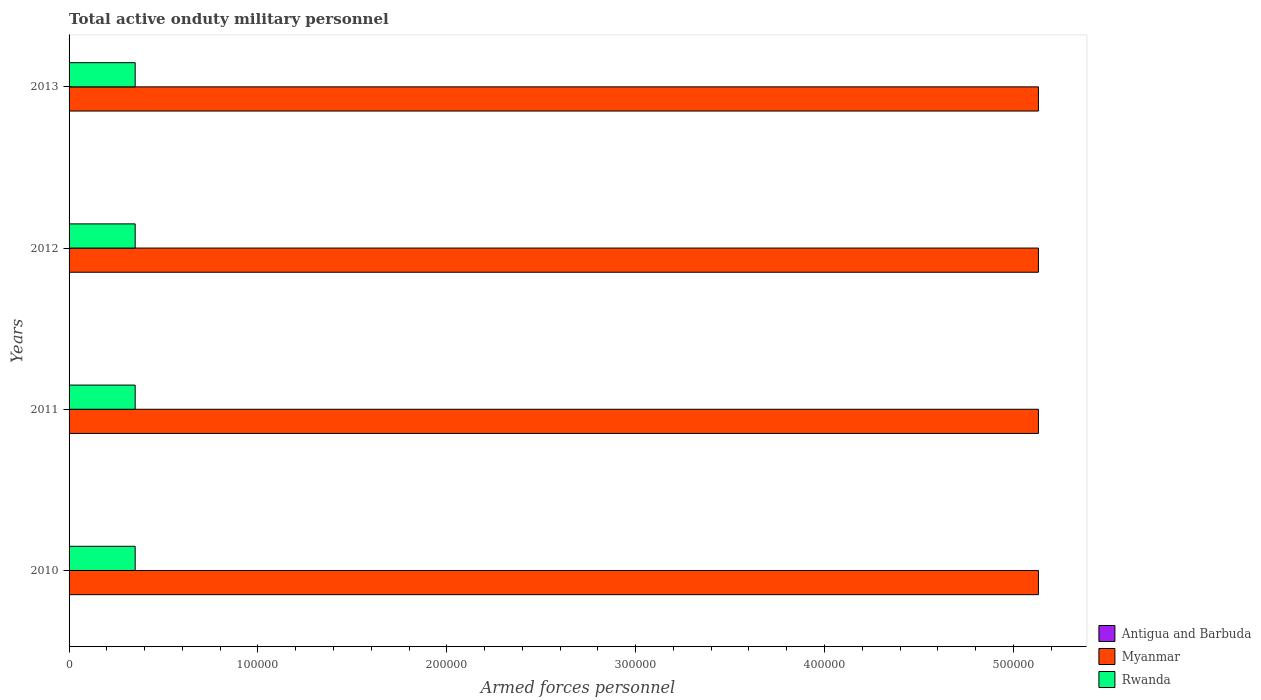Are the number of bars on each tick of the Y-axis equal?
Your response must be concise. Yes. How many bars are there on the 1st tick from the top?
Make the answer very short. 3. How many bars are there on the 2nd tick from the bottom?
Ensure brevity in your answer.  3. What is the label of the 1st group of bars from the top?
Keep it short and to the point. 2013. In how many cases, is the number of bars for a given year not equal to the number of legend labels?
Ensure brevity in your answer.  0. What is the number of armed forces personnel in Myanmar in 2010?
Offer a terse response. 5.13e+05. Across all years, what is the maximum number of armed forces personnel in Rwanda?
Offer a very short reply. 3.50e+04. Across all years, what is the minimum number of armed forces personnel in Rwanda?
Offer a very short reply. 3.50e+04. In which year was the number of armed forces personnel in Antigua and Barbuda maximum?
Your answer should be compact. 2011. What is the total number of armed forces personnel in Myanmar in the graph?
Give a very brief answer. 2.05e+06. What is the difference between the number of armed forces personnel in Rwanda in 2010 and the number of armed forces personnel in Myanmar in 2011?
Your answer should be very brief. -4.78e+05. What is the average number of armed forces personnel in Antigua and Barbuda per year?
Keep it short and to the point. 177.5. In the year 2011, what is the difference between the number of armed forces personnel in Myanmar and number of armed forces personnel in Antigua and Barbuda?
Keep it short and to the point. 5.13e+05. In how many years, is the number of armed forces personnel in Myanmar greater than 360000 ?
Provide a succinct answer. 4. Is the number of armed forces personnel in Antigua and Barbuda in 2010 less than that in 2012?
Give a very brief answer. Yes. What is the difference between the highest and the second highest number of armed forces personnel in Rwanda?
Provide a short and direct response. 0. What is the difference between the highest and the lowest number of armed forces personnel in Myanmar?
Make the answer very short. 0. In how many years, is the number of armed forces personnel in Rwanda greater than the average number of armed forces personnel in Rwanda taken over all years?
Provide a short and direct response. 0. What does the 3rd bar from the top in 2010 represents?
Keep it short and to the point. Antigua and Barbuda. What does the 3rd bar from the bottom in 2011 represents?
Provide a short and direct response. Rwanda. Is it the case that in every year, the sum of the number of armed forces personnel in Antigua and Barbuda and number of armed forces personnel in Myanmar is greater than the number of armed forces personnel in Rwanda?
Your answer should be very brief. Yes. Are all the bars in the graph horizontal?
Offer a very short reply. Yes. How many years are there in the graph?
Offer a very short reply. 4. What is the difference between two consecutive major ticks on the X-axis?
Provide a succinct answer. 1.00e+05. Are the values on the major ticks of X-axis written in scientific E-notation?
Give a very brief answer. No. Does the graph contain grids?
Offer a terse response. No. Where does the legend appear in the graph?
Your answer should be very brief. Bottom right. What is the title of the graph?
Your response must be concise. Total active onduty military personnel. What is the label or title of the X-axis?
Make the answer very short. Armed forces personnel. What is the label or title of the Y-axis?
Provide a short and direct response. Years. What is the Armed forces personnel of Antigua and Barbuda in 2010?
Give a very brief answer. 170. What is the Armed forces personnel of Myanmar in 2010?
Offer a terse response. 5.13e+05. What is the Armed forces personnel of Rwanda in 2010?
Your response must be concise. 3.50e+04. What is the Armed forces personnel of Antigua and Barbuda in 2011?
Give a very brief answer. 180. What is the Armed forces personnel of Myanmar in 2011?
Your answer should be very brief. 5.13e+05. What is the Armed forces personnel in Rwanda in 2011?
Your answer should be compact. 3.50e+04. What is the Armed forces personnel in Antigua and Barbuda in 2012?
Offer a very short reply. 180. What is the Armed forces personnel in Myanmar in 2012?
Offer a very short reply. 5.13e+05. What is the Armed forces personnel of Rwanda in 2012?
Your answer should be compact. 3.50e+04. What is the Armed forces personnel in Antigua and Barbuda in 2013?
Offer a terse response. 180. What is the Armed forces personnel of Myanmar in 2013?
Make the answer very short. 5.13e+05. What is the Armed forces personnel of Rwanda in 2013?
Give a very brief answer. 3.50e+04. Across all years, what is the maximum Armed forces personnel of Antigua and Barbuda?
Ensure brevity in your answer.  180. Across all years, what is the maximum Armed forces personnel of Myanmar?
Offer a terse response. 5.13e+05. Across all years, what is the maximum Armed forces personnel in Rwanda?
Your answer should be very brief. 3.50e+04. Across all years, what is the minimum Armed forces personnel of Antigua and Barbuda?
Make the answer very short. 170. Across all years, what is the minimum Armed forces personnel in Myanmar?
Make the answer very short. 5.13e+05. Across all years, what is the minimum Armed forces personnel in Rwanda?
Provide a short and direct response. 3.50e+04. What is the total Armed forces personnel of Antigua and Barbuda in the graph?
Make the answer very short. 710. What is the total Armed forces personnel of Myanmar in the graph?
Your answer should be very brief. 2.05e+06. What is the difference between the Armed forces personnel in Rwanda in 2010 and that in 2011?
Keep it short and to the point. 0. What is the difference between the Armed forces personnel of Rwanda in 2010 and that in 2012?
Your answer should be very brief. 0. What is the difference between the Armed forces personnel in Myanmar in 2010 and that in 2013?
Ensure brevity in your answer.  0. What is the difference between the Armed forces personnel of Rwanda in 2010 and that in 2013?
Offer a very short reply. 0. What is the difference between the Armed forces personnel of Myanmar in 2011 and that in 2013?
Provide a short and direct response. 0. What is the difference between the Armed forces personnel in Rwanda in 2011 and that in 2013?
Offer a very short reply. 0. What is the difference between the Armed forces personnel of Antigua and Barbuda in 2012 and that in 2013?
Provide a succinct answer. 0. What is the difference between the Armed forces personnel of Myanmar in 2012 and that in 2013?
Give a very brief answer. 0. What is the difference between the Armed forces personnel of Antigua and Barbuda in 2010 and the Armed forces personnel of Myanmar in 2011?
Provide a short and direct response. -5.13e+05. What is the difference between the Armed forces personnel in Antigua and Barbuda in 2010 and the Armed forces personnel in Rwanda in 2011?
Offer a terse response. -3.48e+04. What is the difference between the Armed forces personnel of Myanmar in 2010 and the Armed forces personnel of Rwanda in 2011?
Your answer should be very brief. 4.78e+05. What is the difference between the Armed forces personnel of Antigua and Barbuda in 2010 and the Armed forces personnel of Myanmar in 2012?
Your response must be concise. -5.13e+05. What is the difference between the Armed forces personnel of Antigua and Barbuda in 2010 and the Armed forces personnel of Rwanda in 2012?
Offer a terse response. -3.48e+04. What is the difference between the Armed forces personnel in Myanmar in 2010 and the Armed forces personnel in Rwanda in 2012?
Provide a succinct answer. 4.78e+05. What is the difference between the Armed forces personnel in Antigua and Barbuda in 2010 and the Armed forces personnel in Myanmar in 2013?
Make the answer very short. -5.13e+05. What is the difference between the Armed forces personnel in Antigua and Barbuda in 2010 and the Armed forces personnel in Rwanda in 2013?
Ensure brevity in your answer.  -3.48e+04. What is the difference between the Armed forces personnel in Myanmar in 2010 and the Armed forces personnel in Rwanda in 2013?
Your response must be concise. 4.78e+05. What is the difference between the Armed forces personnel in Antigua and Barbuda in 2011 and the Armed forces personnel in Myanmar in 2012?
Provide a short and direct response. -5.13e+05. What is the difference between the Armed forces personnel of Antigua and Barbuda in 2011 and the Armed forces personnel of Rwanda in 2012?
Ensure brevity in your answer.  -3.48e+04. What is the difference between the Armed forces personnel of Myanmar in 2011 and the Armed forces personnel of Rwanda in 2012?
Keep it short and to the point. 4.78e+05. What is the difference between the Armed forces personnel of Antigua and Barbuda in 2011 and the Armed forces personnel of Myanmar in 2013?
Provide a short and direct response. -5.13e+05. What is the difference between the Armed forces personnel in Antigua and Barbuda in 2011 and the Armed forces personnel in Rwanda in 2013?
Make the answer very short. -3.48e+04. What is the difference between the Armed forces personnel of Myanmar in 2011 and the Armed forces personnel of Rwanda in 2013?
Keep it short and to the point. 4.78e+05. What is the difference between the Armed forces personnel of Antigua and Barbuda in 2012 and the Armed forces personnel of Myanmar in 2013?
Your answer should be compact. -5.13e+05. What is the difference between the Armed forces personnel in Antigua and Barbuda in 2012 and the Armed forces personnel in Rwanda in 2013?
Your response must be concise. -3.48e+04. What is the difference between the Armed forces personnel of Myanmar in 2012 and the Armed forces personnel of Rwanda in 2013?
Make the answer very short. 4.78e+05. What is the average Armed forces personnel in Antigua and Barbuda per year?
Ensure brevity in your answer.  177.5. What is the average Armed forces personnel in Myanmar per year?
Make the answer very short. 5.13e+05. What is the average Armed forces personnel in Rwanda per year?
Your answer should be very brief. 3.50e+04. In the year 2010, what is the difference between the Armed forces personnel in Antigua and Barbuda and Armed forces personnel in Myanmar?
Offer a very short reply. -5.13e+05. In the year 2010, what is the difference between the Armed forces personnel in Antigua and Barbuda and Armed forces personnel in Rwanda?
Your answer should be very brief. -3.48e+04. In the year 2010, what is the difference between the Armed forces personnel in Myanmar and Armed forces personnel in Rwanda?
Your response must be concise. 4.78e+05. In the year 2011, what is the difference between the Armed forces personnel in Antigua and Barbuda and Armed forces personnel in Myanmar?
Keep it short and to the point. -5.13e+05. In the year 2011, what is the difference between the Armed forces personnel of Antigua and Barbuda and Armed forces personnel of Rwanda?
Provide a short and direct response. -3.48e+04. In the year 2011, what is the difference between the Armed forces personnel of Myanmar and Armed forces personnel of Rwanda?
Offer a very short reply. 4.78e+05. In the year 2012, what is the difference between the Armed forces personnel in Antigua and Barbuda and Armed forces personnel in Myanmar?
Offer a terse response. -5.13e+05. In the year 2012, what is the difference between the Armed forces personnel of Antigua and Barbuda and Armed forces personnel of Rwanda?
Make the answer very short. -3.48e+04. In the year 2012, what is the difference between the Armed forces personnel of Myanmar and Armed forces personnel of Rwanda?
Keep it short and to the point. 4.78e+05. In the year 2013, what is the difference between the Armed forces personnel of Antigua and Barbuda and Armed forces personnel of Myanmar?
Your response must be concise. -5.13e+05. In the year 2013, what is the difference between the Armed forces personnel of Antigua and Barbuda and Armed forces personnel of Rwanda?
Your response must be concise. -3.48e+04. In the year 2013, what is the difference between the Armed forces personnel of Myanmar and Armed forces personnel of Rwanda?
Offer a terse response. 4.78e+05. What is the ratio of the Armed forces personnel of Rwanda in 2010 to that in 2011?
Your answer should be very brief. 1. What is the ratio of the Armed forces personnel in Antigua and Barbuda in 2010 to that in 2012?
Your answer should be very brief. 0.94. What is the ratio of the Armed forces personnel in Myanmar in 2010 to that in 2012?
Provide a succinct answer. 1. What is the ratio of the Armed forces personnel of Rwanda in 2010 to that in 2012?
Your answer should be compact. 1. What is the ratio of the Armed forces personnel of Antigua and Barbuda in 2010 to that in 2013?
Provide a succinct answer. 0.94. What is the ratio of the Armed forces personnel in Antigua and Barbuda in 2011 to that in 2012?
Provide a short and direct response. 1. What is the ratio of the Armed forces personnel of Antigua and Barbuda in 2011 to that in 2013?
Keep it short and to the point. 1. What is the ratio of the Armed forces personnel of Rwanda in 2011 to that in 2013?
Provide a short and direct response. 1. What is the ratio of the Armed forces personnel in Myanmar in 2012 to that in 2013?
Keep it short and to the point. 1. What is the difference between the highest and the second highest Armed forces personnel of Antigua and Barbuda?
Your response must be concise. 0. What is the difference between the highest and the second highest Armed forces personnel in Myanmar?
Ensure brevity in your answer.  0. What is the difference between the highest and the second highest Armed forces personnel of Rwanda?
Provide a succinct answer. 0. What is the difference between the highest and the lowest Armed forces personnel of Antigua and Barbuda?
Ensure brevity in your answer.  10. What is the difference between the highest and the lowest Armed forces personnel in Myanmar?
Make the answer very short. 0. What is the difference between the highest and the lowest Armed forces personnel of Rwanda?
Offer a very short reply. 0. 